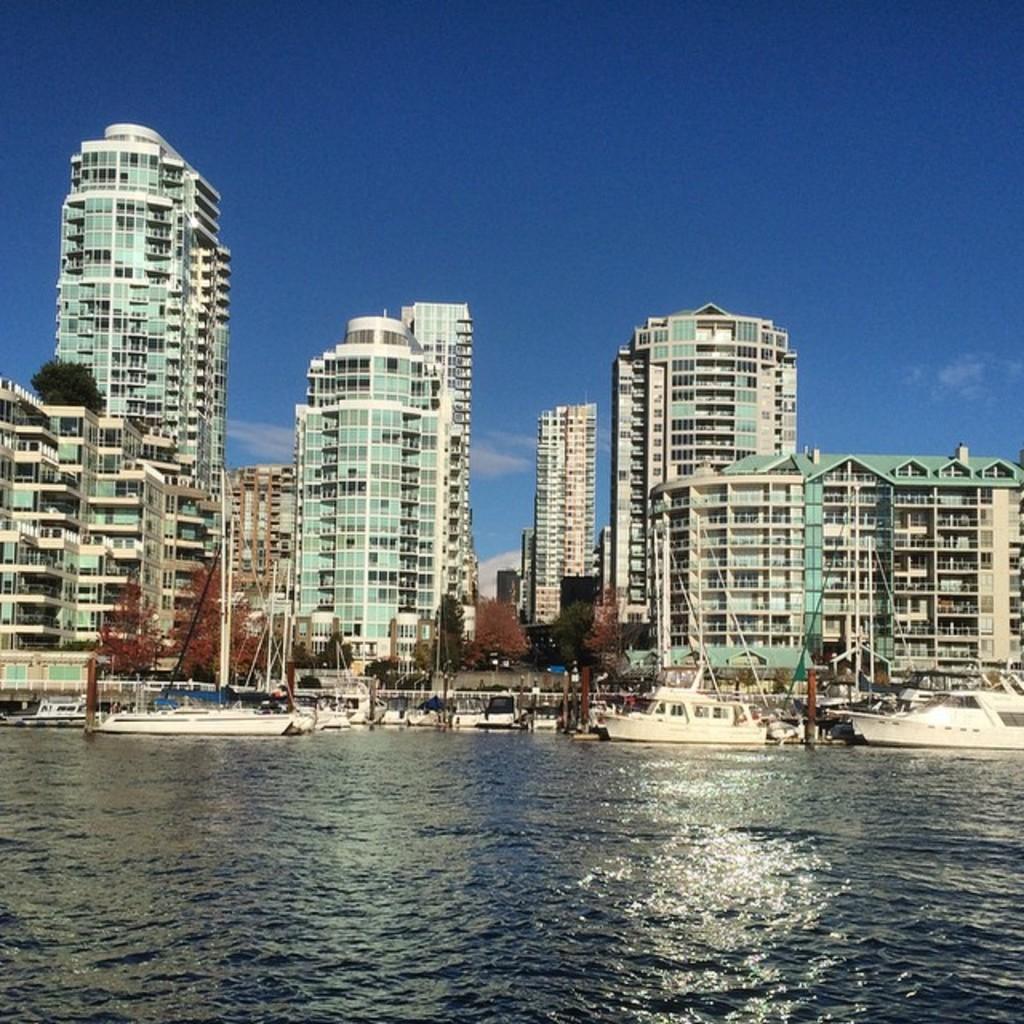Please provide a concise description of this image. At the bottom of this image, there are boats on the water. In the background, there are buildings, trees and there are clouds in the blue sky. 